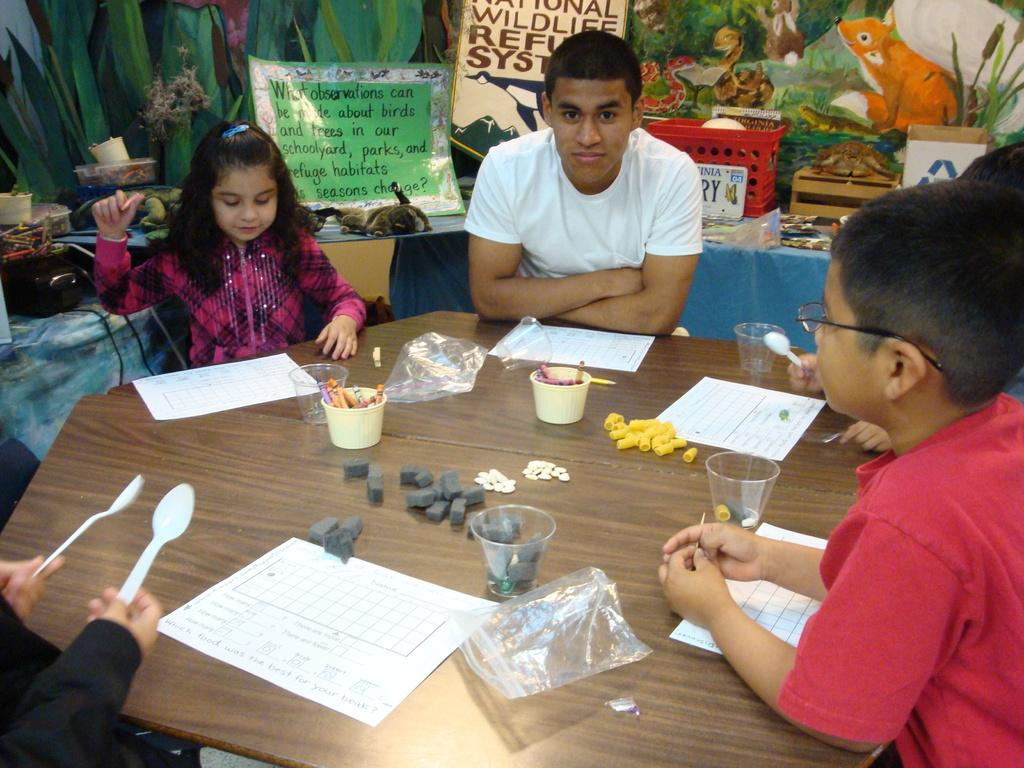What is the main object in the image? There is a table in the image. What are the people in the image doing? People are sitting around the table. What items can be seen on the table? There are papers and spoons on the table. Can you describe the girl in the image? The girl is wearing a pink dress. How is the boy dressed in the image? The boy is wearing a white T-shirt. What type of haircut does the spy have in the image? There is no spy present in the image, and therefore no haircut can be observed. Can you tell me if there is a trail visible in the image? There is no trail visible in the image; it features a table with people sitting around it. 